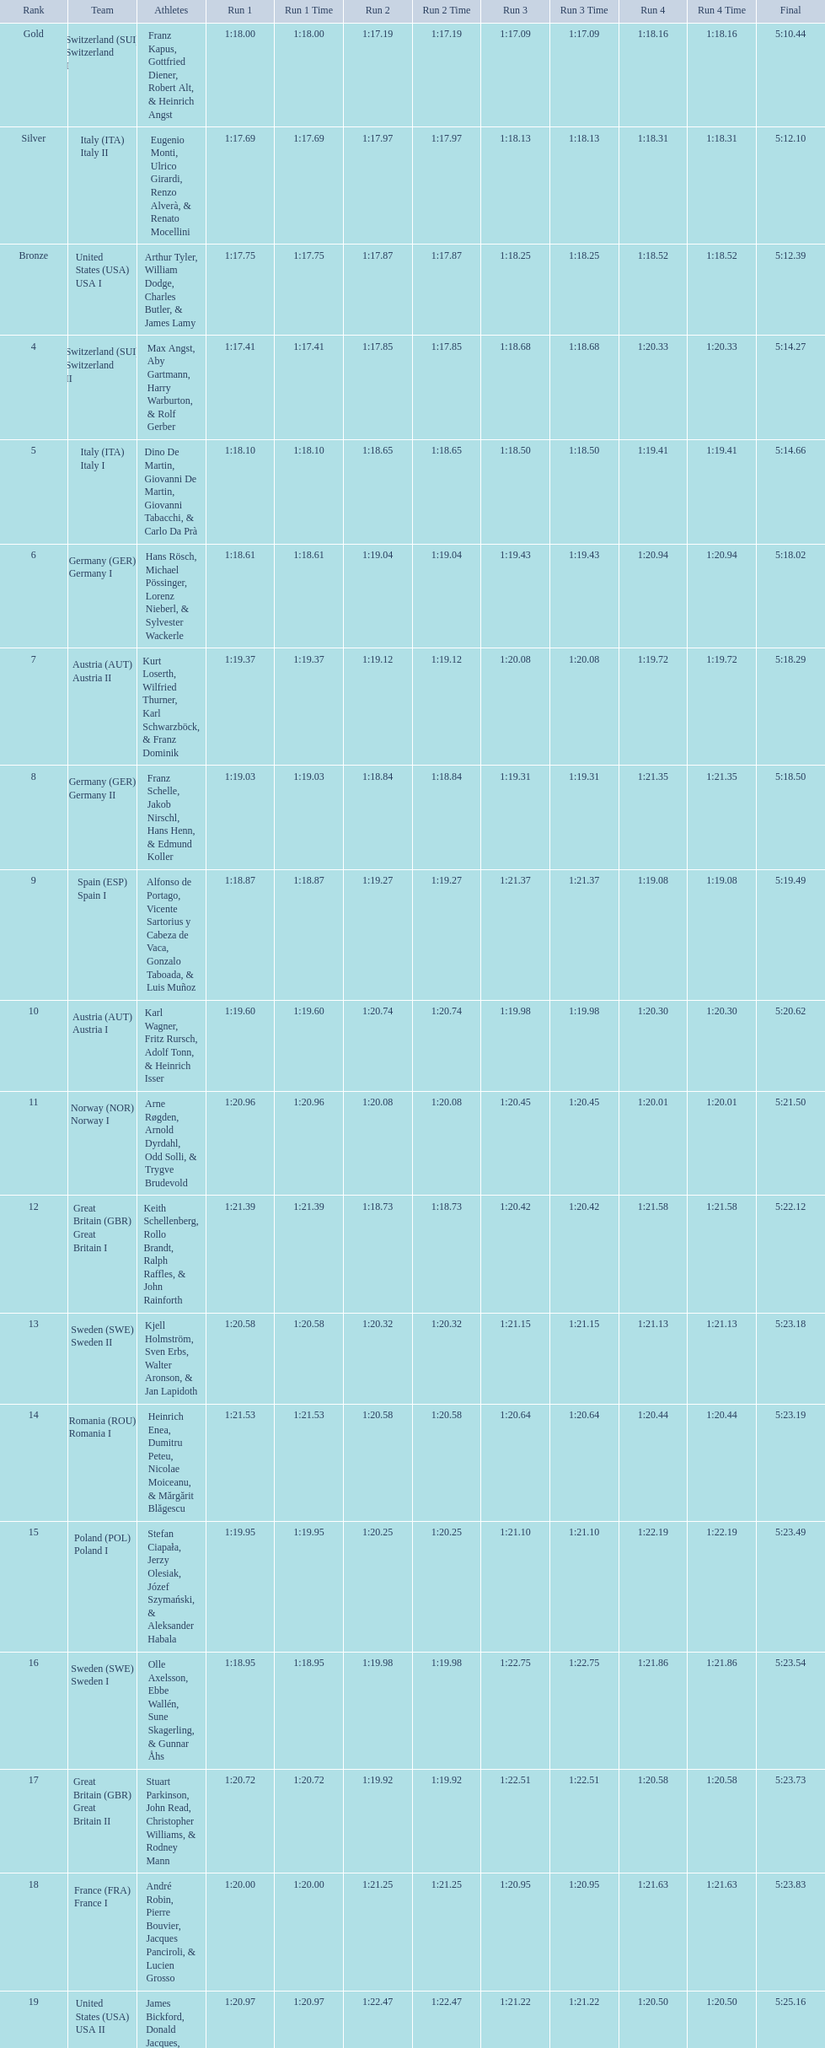What team came out on top? Switzerland. 